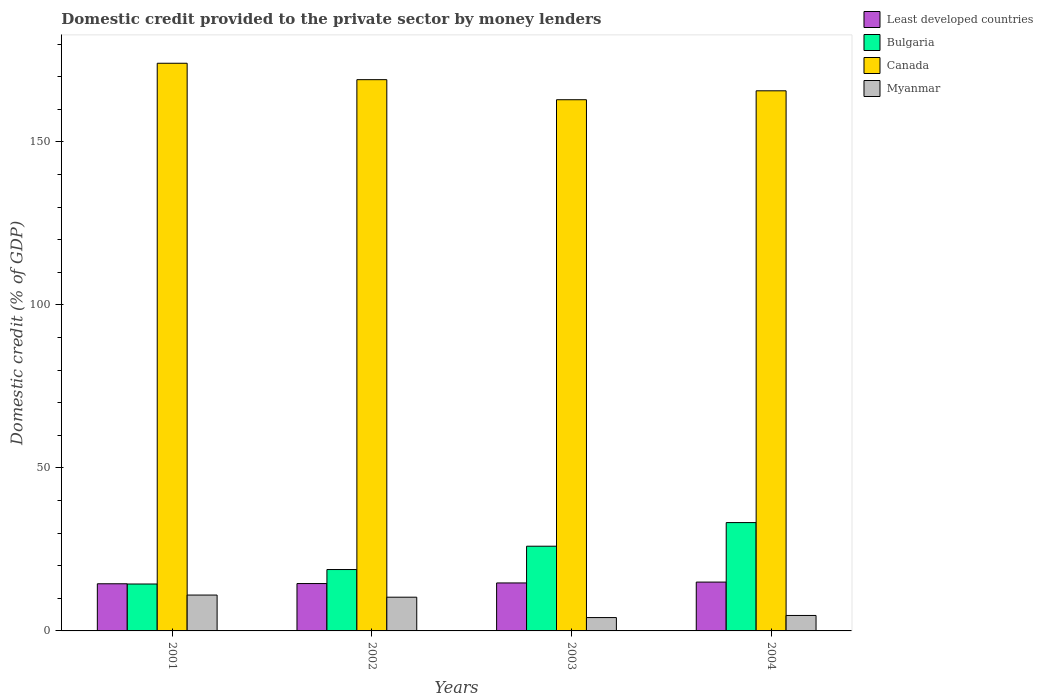How many different coloured bars are there?
Ensure brevity in your answer.  4. How many groups of bars are there?
Make the answer very short. 4. Are the number of bars per tick equal to the number of legend labels?
Your response must be concise. Yes. How many bars are there on the 2nd tick from the left?
Give a very brief answer. 4. How many bars are there on the 3rd tick from the right?
Your answer should be compact. 4. What is the label of the 1st group of bars from the left?
Offer a terse response. 2001. What is the domestic credit provided to the private sector by money lenders in Myanmar in 2003?
Make the answer very short. 4.1. Across all years, what is the maximum domestic credit provided to the private sector by money lenders in Least developed countries?
Your answer should be very brief. 14.98. Across all years, what is the minimum domestic credit provided to the private sector by money lenders in Least developed countries?
Offer a terse response. 14.46. In which year was the domestic credit provided to the private sector by money lenders in Canada maximum?
Ensure brevity in your answer.  2001. What is the total domestic credit provided to the private sector by money lenders in Bulgaria in the graph?
Your answer should be compact. 92.42. What is the difference between the domestic credit provided to the private sector by money lenders in Bulgaria in 2003 and that in 2004?
Ensure brevity in your answer.  -7.24. What is the difference between the domestic credit provided to the private sector by money lenders in Least developed countries in 2002 and the domestic credit provided to the private sector by money lenders in Bulgaria in 2004?
Your answer should be very brief. -18.7. What is the average domestic credit provided to the private sector by money lenders in Myanmar per year?
Your answer should be compact. 7.55. In the year 2003, what is the difference between the domestic credit provided to the private sector by money lenders in Canada and domestic credit provided to the private sector by money lenders in Myanmar?
Give a very brief answer. 158.82. In how many years, is the domestic credit provided to the private sector by money lenders in Bulgaria greater than 50 %?
Offer a terse response. 0. What is the ratio of the domestic credit provided to the private sector by money lenders in Bulgaria in 2001 to that in 2002?
Your response must be concise. 0.76. Is the domestic credit provided to the private sector by money lenders in Bulgaria in 2002 less than that in 2004?
Your response must be concise. Yes. What is the difference between the highest and the second highest domestic credit provided to the private sector by money lenders in Least developed countries?
Provide a short and direct response. 0.26. What is the difference between the highest and the lowest domestic credit provided to the private sector by money lenders in Least developed countries?
Your answer should be very brief. 0.51. Is it the case that in every year, the sum of the domestic credit provided to the private sector by money lenders in Least developed countries and domestic credit provided to the private sector by money lenders in Canada is greater than the sum of domestic credit provided to the private sector by money lenders in Bulgaria and domestic credit provided to the private sector by money lenders in Myanmar?
Provide a short and direct response. Yes. Is it the case that in every year, the sum of the domestic credit provided to the private sector by money lenders in Myanmar and domestic credit provided to the private sector by money lenders in Bulgaria is greater than the domestic credit provided to the private sector by money lenders in Least developed countries?
Your response must be concise. Yes. How many bars are there?
Provide a succinct answer. 16. How many years are there in the graph?
Your answer should be very brief. 4. Are the values on the major ticks of Y-axis written in scientific E-notation?
Keep it short and to the point. No. Does the graph contain any zero values?
Make the answer very short. No. Does the graph contain grids?
Offer a terse response. No. How many legend labels are there?
Ensure brevity in your answer.  4. What is the title of the graph?
Your response must be concise. Domestic credit provided to the private sector by money lenders. Does "Sudan" appear as one of the legend labels in the graph?
Offer a very short reply. No. What is the label or title of the Y-axis?
Your response must be concise. Domestic credit (% of GDP). What is the Domestic credit (% of GDP) of Least developed countries in 2001?
Ensure brevity in your answer.  14.46. What is the Domestic credit (% of GDP) of Bulgaria in 2001?
Ensure brevity in your answer.  14.39. What is the Domestic credit (% of GDP) of Canada in 2001?
Offer a terse response. 174.1. What is the Domestic credit (% of GDP) of Myanmar in 2001?
Ensure brevity in your answer.  11. What is the Domestic credit (% of GDP) of Least developed countries in 2002?
Your answer should be compact. 14.53. What is the Domestic credit (% of GDP) in Bulgaria in 2002?
Your answer should be very brief. 18.83. What is the Domestic credit (% of GDP) in Canada in 2002?
Offer a very short reply. 169.06. What is the Domestic credit (% of GDP) in Myanmar in 2002?
Offer a very short reply. 10.34. What is the Domestic credit (% of GDP) in Least developed countries in 2003?
Give a very brief answer. 14.72. What is the Domestic credit (% of GDP) of Bulgaria in 2003?
Make the answer very short. 25.98. What is the Domestic credit (% of GDP) in Canada in 2003?
Make the answer very short. 162.91. What is the Domestic credit (% of GDP) in Myanmar in 2003?
Provide a short and direct response. 4.1. What is the Domestic credit (% of GDP) in Least developed countries in 2004?
Offer a terse response. 14.98. What is the Domestic credit (% of GDP) in Bulgaria in 2004?
Your answer should be compact. 33.23. What is the Domestic credit (% of GDP) of Canada in 2004?
Your response must be concise. 165.65. What is the Domestic credit (% of GDP) of Myanmar in 2004?
Offer a terse response. 4.74. Across all years, what is the maximum Domestic credit (% of GDP) in Least developed countries?
Keep it short and to the point. 14.98. Across all years, what is the maximum Domestic credit (% of GDP) of Bulgaria?
Your answer should be very brief. 33.23. Across all years, what is the maximum Domestic credit (% of GDP) of Canada?
Make the answer very short. 174.1. Across all years, what is the maximum Domestic credit (% of GDP) in Myanmar?
Offer a terse response. 11. Across all years, what is the minimum Domestic credit (% of GDP) of Least developed countries?
Offer a very short reply. 14.46. Across all years, what is the minimum Domestic credit (% of GDP) in Bulgaria?
Your answer should be compact. 14.39. Across all years, what is the minimum Domestic credit (% of GDP) in Canada?
Make the answer very short. 162.91. Across all years, what is the minimum Domestic credit (% of GDP) in Myanmar?
Give a very brief answer. 4.1. What is the total Domestic credit (% of GDP) in Least developed countries in the graph?
Offer a terse response. 58.68. What is the total Domestic credit (% of GDP) of Bulgaria in the graph?
Your answer should be compact. 92.42. What is the total Domestic credit (% of GDP) of Canada in the graph?
Offer a terse response. 671.73. What is the total Domestic credit (% of GDP) of Myanmar in the graph?
Provide a succinct answer. 30.18. What is the difference between the Domestic credit (% of GDP) of Least developed countries in 2001 and that in 2002?
Your answer should be compact. -0.06. What is the difference between the Domestic credit (% of GDP) of Bulgaria in 2001 and that in 2002?
Offer a very short reply. -4.44. What is the difference between the Domestic credit (% of GDP) in Canada in 2001 and that in 2002?
Your answer should be very brief. 5.03. What is the difference between the Domestic credit (% of GDP) in Myanmar in 2001 and that in 2002?
Ensure brevity in your answer.  0.66. What is the difference between the Domestic credit (% of GDP) of Least developed countries in 2001 and that in 2003?
Provide a short and direct response. -0.25. What is the difference between the Domestic credit (% of GDP) of Bulgaria in 2001 and that in 2003?
Provide a succinct answer. -11.59. What is the difference between the Domestic credit (% of GDP) in Canada in 2001 and that in 2003?
Offer a terse response. 11.18. What is the difference between the Domestic credit (% of GDP) in Myanmar in 2001 and that in 2003?
Keep it short and to the point. 6.91. What is the difference between the Domestic credit (% of GDP) in Least developed countries in 2001 and that in 2004?
Give a very brief answer. -0.51. What is the difference between the Domestic credit (% of GDP) in Bulgaria in 2001 and that in 2004?
Provide a succinct answer. -18.84. What is the difference between the Domestic credit (% of GDP) in Canada in 2001 and that in 2004?
Your answer should be compact. 8.45. What is the difference between the Domestic credit (% of GDP) in Myanmar in 2001 and that in 2004?
Your answer should be compact. 6.26. What is the difference between the Domestic credit (% of GDP) in Least developed countries in 2002 and that in 2003?
Your response must be concise. -0.19. What is the difference between the Domestic credit (% of GDP) in Bulgaria in 2002 and that in 2003?
Provide a short and direct response. -7.16. What is the difference between the Domestic credit (% of GDP) of Canada in 2002 and that in 2003?
Provide a short and direct response. 6.15. What is the difference between the Domestic credit (% of GDP) of Myanmar in 2002 and that in 2003?
Your response must be concise. 6.25. What is the difference between the Domestic credit (% of GDP) in Least developed countries in 2002 and that in 2004?
Your response must be concise. -0.45. What is the difference between the Domestic credit (% of GDP) of Bulgaria in 2002 and that in 2004?
Keep it short and to the point. -14.4. What is the difference between the Domestic credit (% of GDP) in Canada in 2002 and that in 2004?
Your answer should be compact. 3.41. What is the difference between the Domestic credit (% of GDP) of Myanmar in 2002 and that in 2004?
Provide a succinct answer. 5.6. What is the difference between the Domestic credit (% of GDP) of Least developed countries in 2003 and that in 2004?
Provide a short and direct response. -0.26. What is the difference between the Domestic credit (% of GDP) in Bulgaria in 2003 and that in 2004?
Ensure brevity in your answer.  -7.24. What is the difference between the Domestic credit (% of GDP) in Canada in 2003 and that in 2004?
Offer a terse response. -2.74. What is the difference between the Domestic credit (% of GDP) in Myanmar in 2003 and that in 2004?
Provide a succinct answer. -0.64. What is the difference between the Domestic credit (% of GDP) in Least developed countries in 2001 and the Domestic credit (% of GDP) in Bulgaria in 2002?
Give a very brief answer. -4.36. What is the difference between the Domestic credit (% of GDP) in Least developed countries in 2001 and the Domestic credit (% of GDP) in Canada in 2002?
Offer a very short reply. -154.6. What is the difference between the Domestic credit (% of GDP) of Least developed countries in 2001 and the Domestic credit (% of GDP) of Myanmar in 2002?
Provide a succinct answer. 4.12. What is the difference between the Domestic credit (% of GDP) in Bulgaria in 2001 and the Domestic credit (% of GDP) in Canada in 2002?
Give a very brief answer. -154.68. What is the difference between the Domestic credit (% of GDP) of Bulgaria in 2001 and the Domestic credit (% of GDP) of Myanmar in 2002?
Your response must be concise. 4.04. What is the difference between the Domestic credit (% of GDP) in Canada in 2001 and the Domestic credit (% of GDP) in Myanmar in 2002?
Make the answer very short. 163.75. What is the difference between the Domestic credit (% of GDP) in Least developed countries in 2001 and the Domestic credit (% of GDP) in Bulgaria in 2003?
Provide a short and direct response. -11.52. What is the difference between the Domestic credit (% of GDP) in Least developed countries in 2001 and the Domestic credit (% of GDP) in Canada in 2003?
Ensure brevity in your answer.  -148.45. What is the difference between the Domestic credit (% of GDP) in Least developed countries in 2001 and the Domestic credit (% of GDP) in Myanmar in 2003?
Ensure brevity in your answer.  10.37. What is the difference between the Domestic credit (% of GDP) of Bulgaria in 2001 and the Domestic credit (% of GDP) of Canada in 2003?
Make the answer very short. -148.53. What is the difference between the Domestic credit (% of GDP) of Bulgaria in 2001 and the Domestic credit (% of GDP) of Myanmar in 2003?
Your response must be concise. 10.29. What is the difference between the Domestic credit (% of GDP) of Canada in 2001 and the Domestic credit (% of GDP) of Myanmar in 2003?
Keep it short and to the point. 170. What is the difference between the Domestic credit (% of GDP) of Least developed countries in 2001 and the Domestic credit (% of GDP) of Bulgaria in 2004?
Offer a very short reply. -18.76. What is the difference between the Domestic credit (% of GDP) in Least developed countries in 2001 and the Domestic credit (% of GDP) in Canada in 2004?
Provide a succinct answer. -151.19. What is the difference between the Domestic credit (% of GDP) in Least developed countries in 2001 and the Domestic credit (% of GDP) in Myanmar in 2004?
Offer a very short reply. 9.72. What is the difference between the Domestic credit (% of GDP) in Bulgaria in 2001 and the Domestic credit (% of GDP) in Canada in 2004?
Offer a very short reply. -151.26. What is the difference between the Domestic credit (% of GDP) in Bulgaria in 2001 and the Domestic credit (% of GDP) in Myanmar in 2004?
Provide a succinct answer. 9.65. What is the difference between the Domestic credit (% of GDP) of Canada in 2001 and the Domestic credit (% of GDP) of Myanmar in 2004?
Your answer should be compact. 169.36. What is the difference between the Domestic credit (% of GDP) in Least developed countries in 2002 and the Domestic credit (% of GDP) in Bulgaria in 2003?
Offer a terse response. -11.45. What is the difference between the Domestic credit (% of GDP) in Least developed countries in 2002 and the Domestic credit (% of GDP) in Canada in 2003?
Provide a succinct answer. -148.39. What is the difference between the Domestic credit (% of GDP) in Least developed countries in 2002 and the Domestic credit (% of GDP) in Myanmar in 2003?
Make the answer very short. 10.43. What is the difference between the Domestic credit (% of GDP) of Bulgaria in 2002 and the Domestic credit (% of GDP) of Canada in 2003?
Your answer should be very brief. -144.09. What is the difference between the Domestic credit (% of GDP) of Bulgaria in 2002 and the Domestic credit (% of GDP) of Myanmar in 2003?
Ensure brevity in your answer.  14.73. What is the difference between the Domestic credit (% of GDP) in Canada in 2002 and the Domestic credit (% of GDP) in Myanmar in 2003?
Offer a very short reply. 164.97. What is the difference between the Domestic credit (% of GDP) of Least developed countries in 2002 and the Domestic credit (% of GDP) of Bulgaria in 2004?
Your response must be concise. -18.7. What is the difference between the Domestic credit (% of GDP) in Least developed countries in 2002 and the Domestic credit (% of GDP) in Canada in 2004?
Give a very brief answer. -151.12. What is the difference between the Domestic credit (% of GDP) of Least developed countries in 2002 and the Domestic credit (% of GDP) of Myanmar in 2004?
Make the answer very short. 9.79. What is the difference between the Domestic credit (% of GDP) in Bulgaria in 2002 and the Domestic credit (% of GDP) in Canada in 2004?
Provide a short and direct response. -146.82. What is the difference between the Domestic credit (% of GDP) of Bulgaria in 2002 and the Domestic credit (% of GDP) of Myanmar in 2004?
Keep it short and to the point. 14.09. What is the difference between the Domestic credit (% of GDP) in Canada in 2002 and the Domestic credit (% of GDP) in Myanmar in 2004?
Keep it short and to the point. 164.32. What is the difference between the Domestic credit (% of GDP) in Least developed countries in 2003 and the Domestic credit (% of GDP) in Bulgaria in 2004?
Provide a short and direct response. -18.51. What is the difference between the Domestic credit (% of GDP) of Least developed countries in 2003 and the Domestic credit (% of GDP) of Canada in 2004?
Give a very brief answer. -150.93. What is the difference between the Domestic credit (% of GDP) of Least developed countries in 2003 and the Domestic credit (% of GDP) of Myanmar in 2004?
Ensure brevity in your answer.  9.98. What is the difference between the Domestic credit (% of GDP) in Bulgaria in 2003 and the Domestic credit (% of GDP) in Canada in 2004?
Your response must be concise. -139.67. What is the difference between the Domestic credit (% of GDP) of Bulgaria in 2003 and the Domestic credit (% of GDP) of Myanmar in 2004?
Provide a succinct answer. 21.24. What is the difference between the Domestic credit (% of GDP) of Canada in 2003 and the Domestic credit (% of GDP) of Myanmar in 2004?
Your answer should be compact. 158.17. What is the average Domestic credit (% of GDP) of Least developed countries per year?
Provide a succinct answer. 14.67. What is the average Domestic credit (% of GDP) in Bulgaria per year?
Provide a short and direct response. 23.1. What is the average Domestic credit (% of GDP) of Canada per year?
Your response must be concise. 167.93. What is the average Domestic credit (% of GDP) in Myanmar per year?
Give a very brief answer. 7.55. In the year 2001, what is the difference between the Domestic credit (% of GDP) of Least developed countries and Domestic credit (% of GDP) of Bulgaria?
Keep it short and to the point. 0.08. In the year 2001, what is the difference between the Domestic credit (% of GDP) in Least developed countries and Domestic credit (% of GDP) in Canada?
Your answer should be compact. -159.64. In the year 2001, what is the difference between the Domestic credit (% of GDP) of Least developed countries and Domestic credit (% of GDP) of Myanmar?
Your answer should be very brief. 3.46. In the year 2001, what is the difference between the Domestic credit (% of GDP) of Bulgaria and Domestic credit (% of GDP) of Canada?
Offer a very short reply. -159.71. In the year 2001, what is the difference between the Domestic credit (% of GDP) of Bulgaria and Domestic credit (% of GDP) of Myanmar?
Ensure brevity in your answer.  3.38. In the year 2001, what is the difference between the Domestic credit (% of GDP) of Canada and Domestic credit (% of GDP) of Myanmar?
Offer a terse response. 163.1. In the year 2002, what is the difference between the Domestic credit (% of GDP) of Least developed countries and Domestic credit (% of GDP) of Bulgaria?
Ensure brevity in your answer.  -4.3. In the year 2002, what is the difference between the Domestic credit (% of GDP) in Least developed countries and Domestic credit (% of GDP) in Canada?
Give a very brief answer. -154.54. In the year 2002, what is the difference between the Domestic credit (% of GDP) of Least developed countries and Domestic credit (% of GDP) of Myanmar?
Make the answer very short. 4.18. In the year 2002, what is the difference between the Domestic credit (% of GDP) in Bulgaria and Domestic credit (% of GDP) in Canada?
Keep it short and to the point. -150.24. In the year 2002, what is the difference between the Domestic credit (% of GDP) of Bulgaria and Domestic credit (% of GDP) of Myanmar?
Provide a succinct answer. 8.48. In the year 2002, what is the difference between the Domestic credit (% of GDP) of Canada and Domestic credit (% of GDP) of Myanmar?
Offer a very short reply. 158.72. In the year 2003, what is the difference between the Domestic credit (% of GDP) of Least developed countries and Domestic credit (% of GDP) of Bulgaria?
Ensure brevity in your answer.  -11.27. In the year 2003, what is the difference between the Domestic credit (% of GDP) of Least developed countries and Domestic credit (% of GDP) of Canada?
Offer a very short reply. -148.2. In the year 2003, what is the difference between the Domestic credit (% of GDP) of Least developed countries and Domestic credit (% of GDP) of Myanmar?
Your answer should be very brief. 10.62. In the year 2003, what is the difference between the Domestic credit (% of GDP) of Bulgaria and Domestic credit (% of GDP) of Canada?
Ensure brevity in your answer.  -136.93. In the year 2003, what is the difference between the Domestic credit (% of GDP) of Bulgaria and Domestic credit (% of GDP) of Myanmar?
Keep it short and to the point. 21.89. In the year 2003, what is the difference between the Domestic credit (% of GDP) in Canada and Domestic credit (% of GDP) in Myanmar?
Your response must be concise. 158.82. In the year 2004, what is the difference between the Domestic credit (% of GDP) of Least developed countries and Domestic credit (% of GDP) of Bulgaria?
Make the answer very short. -18.25. In the year 2004, what is the difference between the Domestic credit (% of GDP) of Least developed countries and Domestic credit (% of GDP) of Canada?
Provide a succinct answer. -150.67. In the year 2004, what is the difference between the Domestic credit (% of GDP) in Least developed countries and Domestic credit (% of GDP) in Myanmar?
Offer a terse response. 10.24. In the year 2004, what is the difference between the Domestic credit (% of GDP) of Bulgaria and Domestic credit (% of GDP) of Canada?
Your answer should be very brief. -132.43. In the year 2004, what is the difference between the Domestic credit (% of GDP) of Bulgaria and Domestic credit (% of GDP) of Myanmar?
Your answer should be very brief. 28.48. In the year 2004, what is the difference between the Domestic credit (% of GDP) in Canada and Domestic credit (% of GDP) in Myanmar?
Give a very brief answer. 160.91. What is the ratio of the Domestic credit (% of GDP) in Bulgaria in 2001 to that in 2002?
Provide a short and direct response. 0.76. What is the ratio of the Domestic credit (% of GDP) in Canada in 2001 to that in 2002?
Give a very brief answer. 1.03. What is the ratio of the Domestic credit (% of GDP) in Myanmar in 2001 to that in 2002?
Ensure brevity in your answer.  1.06. What is the ratio of the Domestic credit (% of GDP) of Least developed countries in 2001 to that in 2003?
Make the answer very short. 0.98. What is the ratio of the Domestic credit (% of GDP) of Bulgaria in 2001 to that in 2003?
Offer a terse response. 0.55. What is the ratio of the Domestic credit (% of GDP) in Canada in 2001 to that in 2003?
Your answer should be very brief. 1.07. What is the ratio of the Domestic credit (% of GDP) in Myanmar in 2001 to that in 2003?
Ensure brevity in your answer.  2.69. What is the ratio of the Domestic credit (% of GDP) of Least developed countries in 2001 to that in 2004?
Offer a very short reply. 0.97. What is the ratio of the Domestic credit (% of GDP) in Bulgaria in 2001 to that in 2004?
Your response must be concise. 0.43. What is the ratio of the Domestic credit (% of GDP) of Canada in 2001 to that in 2004?
Offer a terse response. 1.05. What is the ratio of the Domestic credit (% of GDP) of Myanmar in 2001 to that in 2004?
Give a very brief answer. 2.32. What is the ratio of the Domestic credit (% of GDP) in Least developed countries in 2002 to that in 2003?
Offer a very short reply. 0.99. What is the ratio of the Domestic credit (% of GDP) in Bulgaria in 2002 to that in 2003?
Keep it short and to the point. 0.72. What is the ratio of the Domestic credit (% of GDP) of Canada in 2002 to that in 2003?
Make the answer very short. 1.04. What is the ratio of the Domestic credit (% of GDP) of Myanmar in 2002 to that in 2003?
Give a very brief answer. 2.53. What is the ratio of the Domestic credit (% of GDP) of Bulgaria in 2002 to that in 2004?
Your answer should be very brief. 0.57. What is the ratio of the Domestic credit (% of GDP) of Canada in 2002 to that in 2004?
Your answer should be very brief. 1.02. What is the ratio of the Domestic credit (% of GDP) of Myanmar in 2002 to that in 2004?
Make the answer very short. 2.18. What is the ratio of the Domestic credit (% of GDP) of Least developed countries in 2003 to that in 2004?
Provide a succinct answer. 0.98. What is the ratio of the Domestic credit (% of GDP) in Bulgaria in 2003 to that in 2004?
Offer a very short reply. 0.78. What is the ratio of the Domestic credit (% of GDP) of Canada in 2003 to that in 2004?
Make the answer very short. 0.98. What is the ratio of the Domestic credit (% of GDP) in Myanmar in 2003 to that in 2004?
Make the answer very short. 0.86. What is the difference between the highest and the second highest Domestic credit (% of GDP) in Least developed countries?
Provide a succinct answer. 0.26. What is the difference between the highest and the second highest Domestic credit (% of GDP) in Bulgaria?
Offer a terse response. 7.24. What is the difference between the highest and the second highest Domestic credit (% of GDP) in Canada?
Your answer should be compact. 5.03. What is the difference between the highest and the second highest Domestic credit (% of GDP) in Myanmar?
Ensure brevity in your answer.  0.66. What is the difference between the highest and the lowest Domestic credit (% of GDP) of Least developed countries?
Your answer should be compact. 0.51. What is the difference between the highest and the lowest Domestic credit (% of GDP) in Bulgaria?
Offer a very short reply. 18.84. What is the difference between the highest and the lowest Domestic credit (% of GDP) of Canada?
Give a very brief answer. 11.18. What is the difference between the highest and the lowest Domestic credit (% of GDP) in Myanmar?
Offer a terse response. 6.91. 